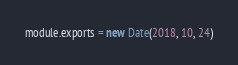Convert code to text. <code><loc_0><loc_0><loc_500><loc_500><_JavaScript_>module.exports = new Date(2018, 10, 24)
</code> 